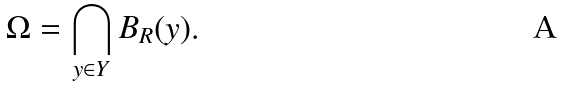<formula> <loc_0><loc_0><loc_500><loc_500>\Omega = \bigcap _ { y \in Y } B _ { R } ( y ) .</formula> 